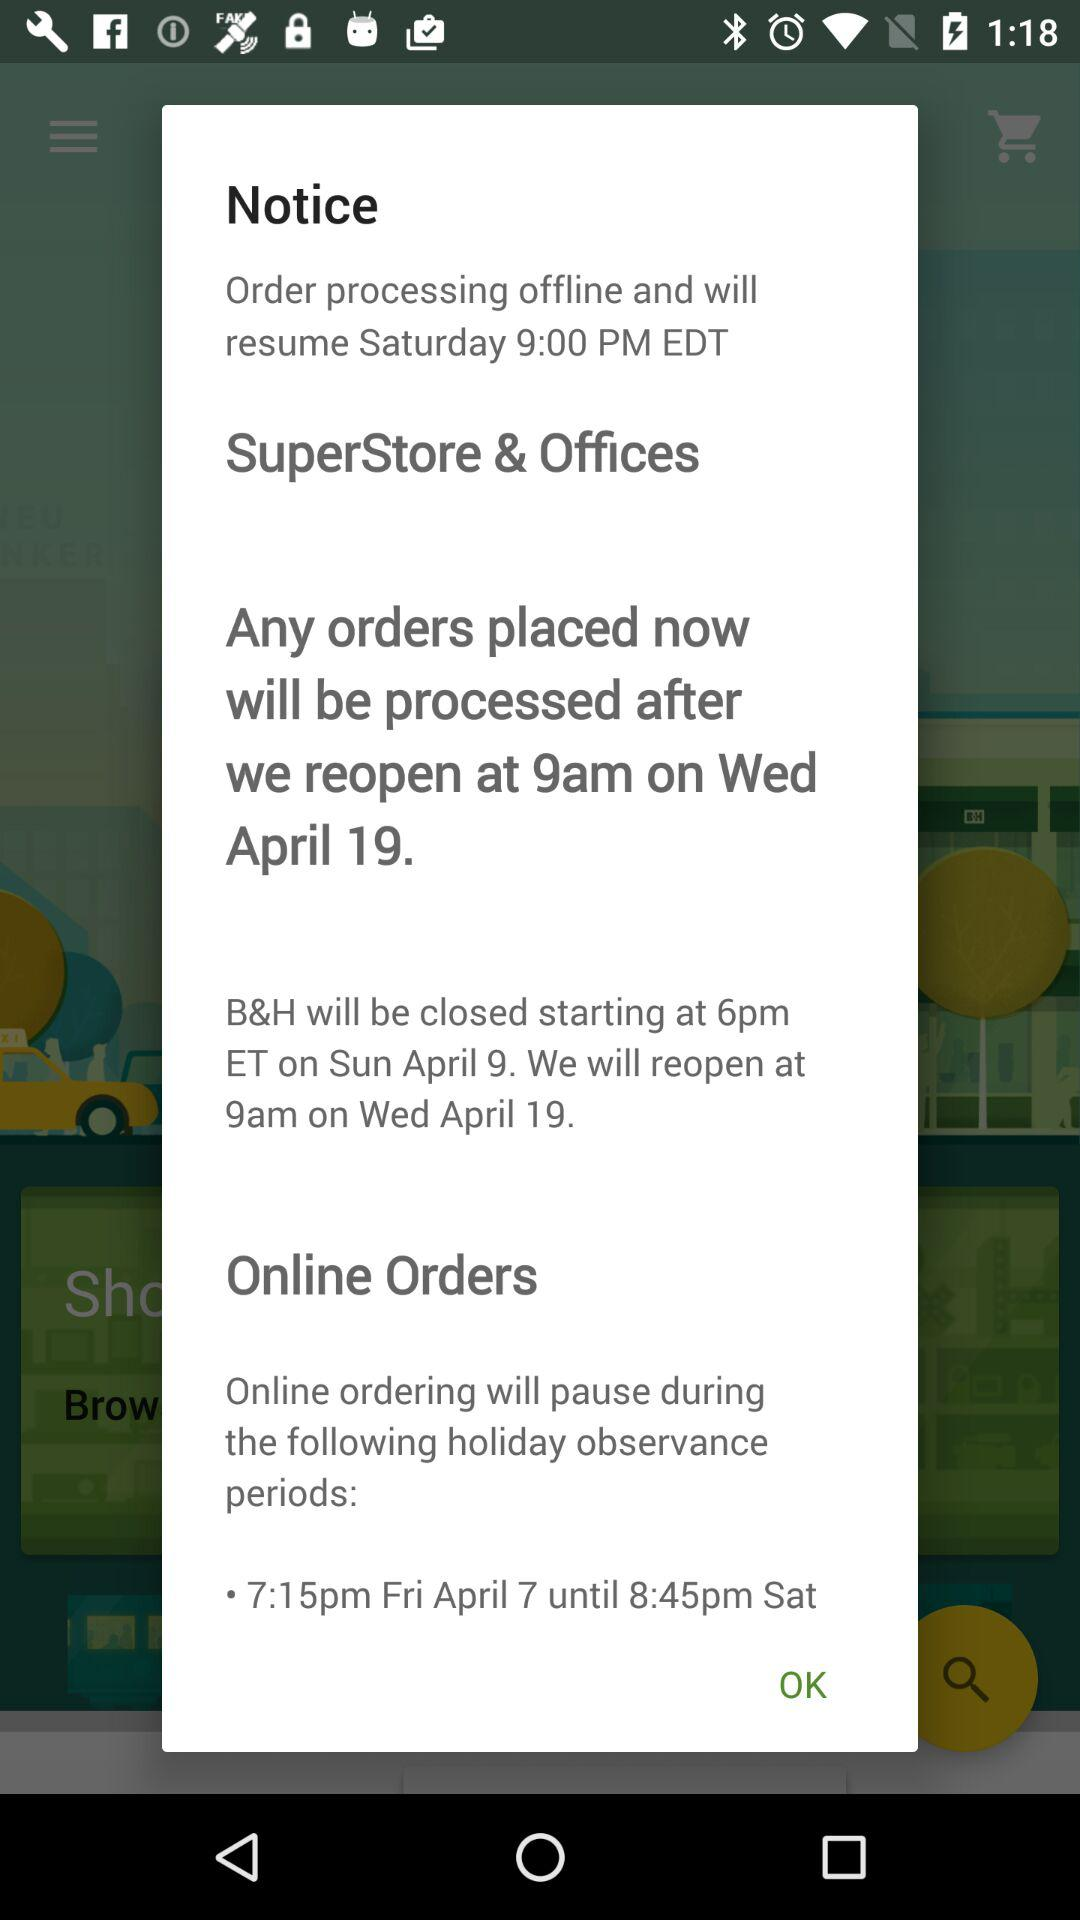For what duration will online ordering be paused? Online ordering will be paused from 7:15 p.m. on Friday, April 7, until 8:45 p.m. on Saturday. 